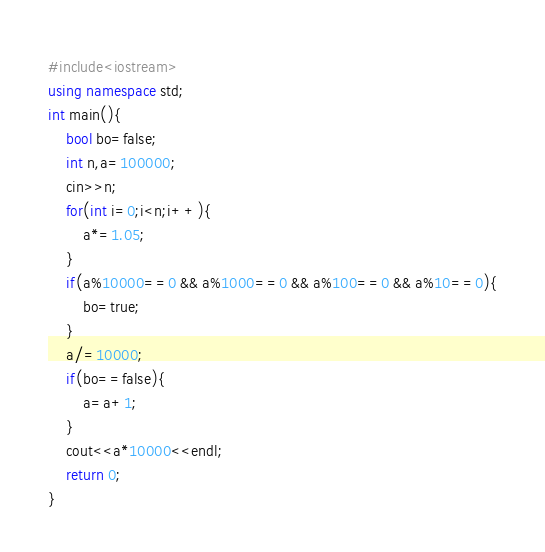Convert code to text. <code><loc_0><loc_0><loc_500><loc_500><_C++_>#include<iostream>
using namespace std;
int main(){
	bool bo=false;
	int n,a=100000;
	cin>>n;
	for(int i=0;i<n;i++){
		a*=1.05;
	}
	if(a%10000==0 && a%1000==0 && a%100==0 && a%10==0){
		bo=true;
	}
	a/=10000;
	if(bo==false){
		a=a+1;
	}
	cout<<a*10000<<endl;
	return 0;
}</code> 